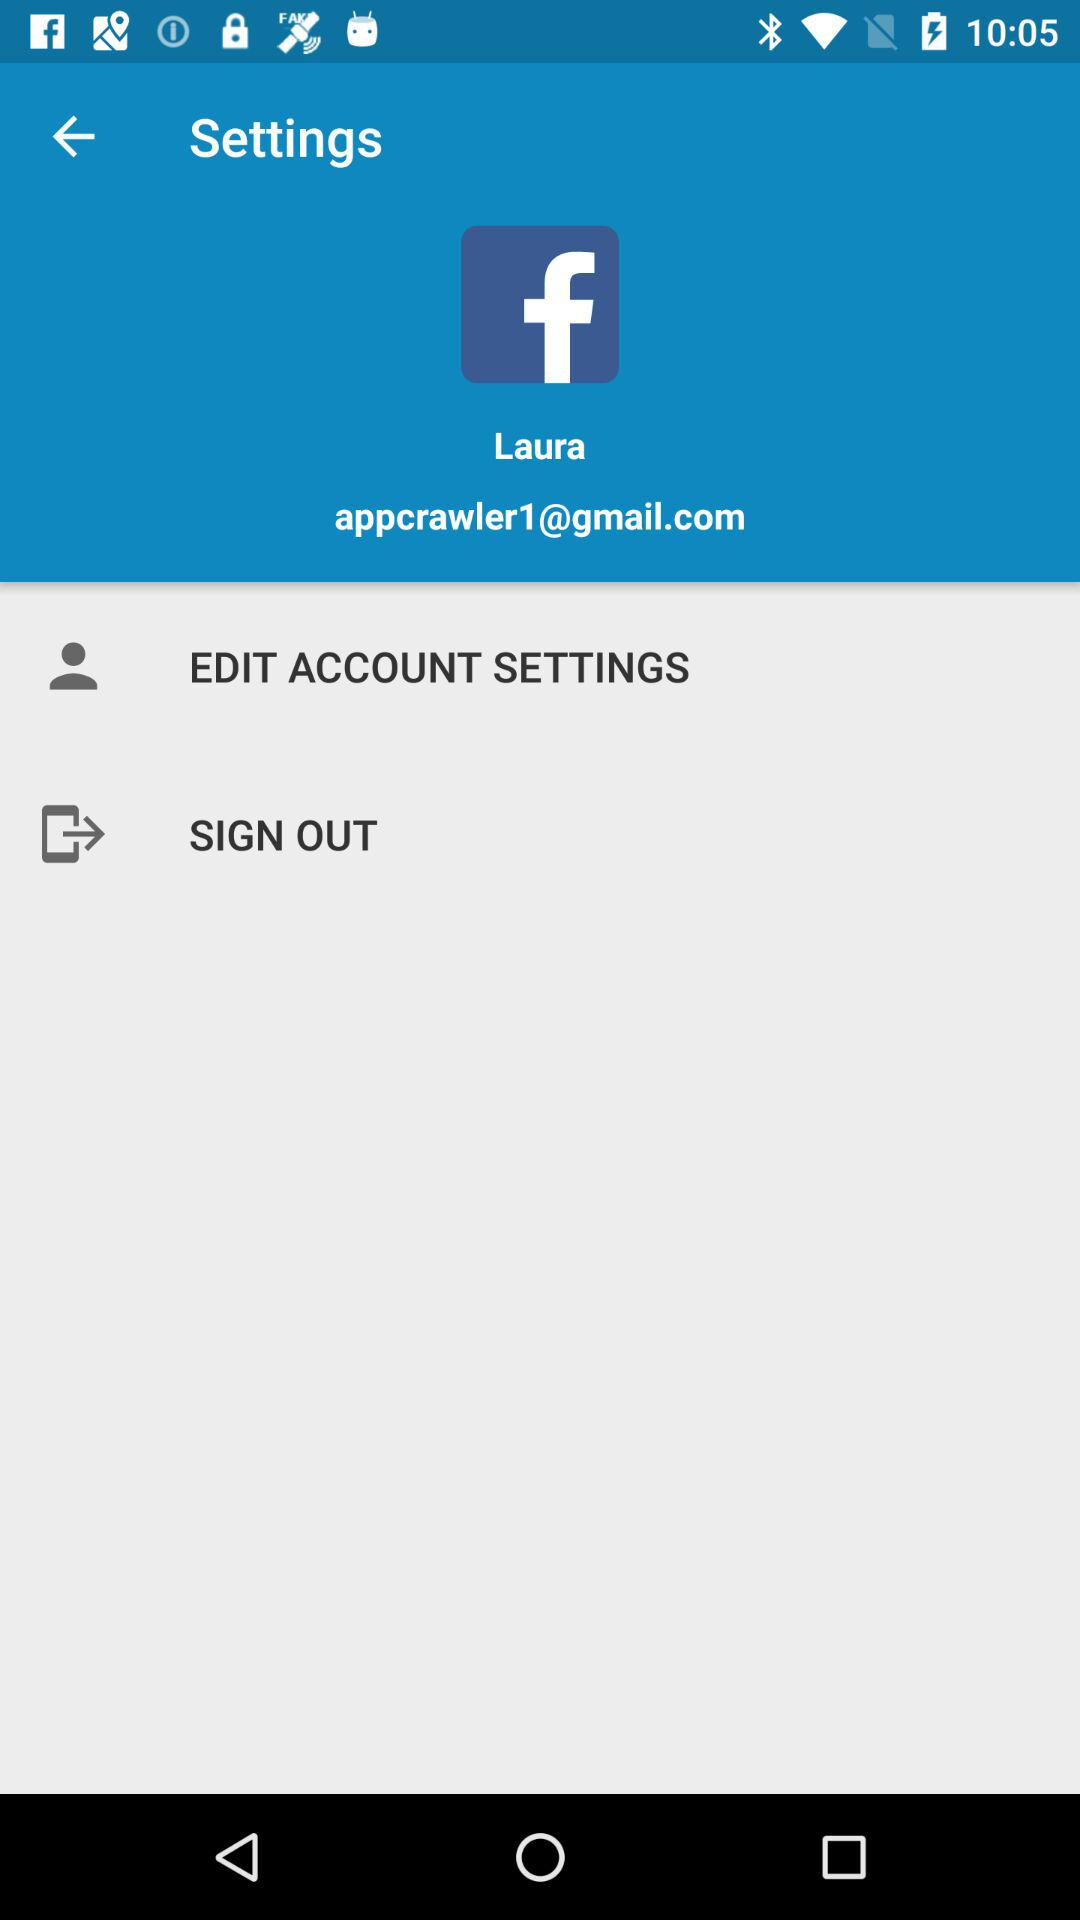What is the name of the user? The name of the user is Laura. 